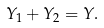<formula> <loc_0><loc_0><loc_500><loc_500>Y _ { 1 } + Y _ { 2 } = Y .</formula> 